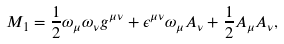<formula> <loc_0><loc_0><loc_500><loc_500>M _ { 1 } = \frac { 1 } { 2 } \omega _ { \mu } \omega _ { \nu } g ^ { \mu \nu } + \epsilon ^ { \mu \nu } \omega _ { \mu } A _ { \nu } + \frac { 1 } { 2 } A _ { \mu } A _ { \nu } ,</formula> 